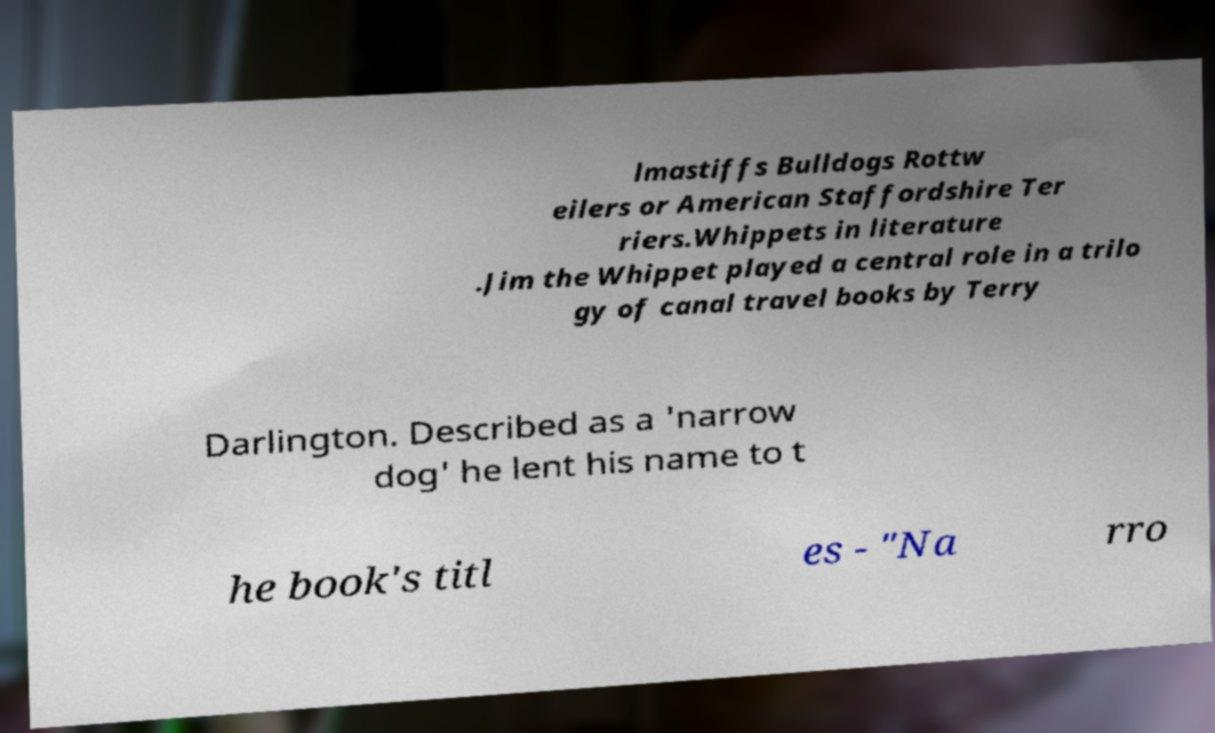Can you accurately transcribe the text from the provided image for me? lmastiffs Bulldogs Rottw eilers or American Staffordshire Ter riers.Whippets in literature .Jim the Whippet played a central role in a trilo gy of canal travel books by Terry Darlington. Described as a 'narrow dog' he lent his name to t he book's titl es - "Na rro 